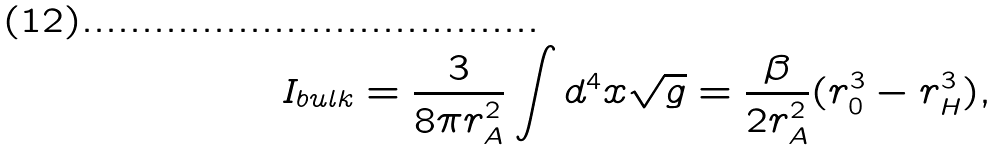<formula> <loc_0><loc_0><loc_500><loc_500>I _ { b u l k } = \frac { 3 } { 8 \pi r _ { A } ^ { 2 } } \int d ^ { 4 } x \sqrt { g } = \frac { \beta } { 2 r _ { A } ^ { 2 } } ( r _ { 0 } ^ { 3 } - r _ { H } ^ { 3 } ) ,</formula> 